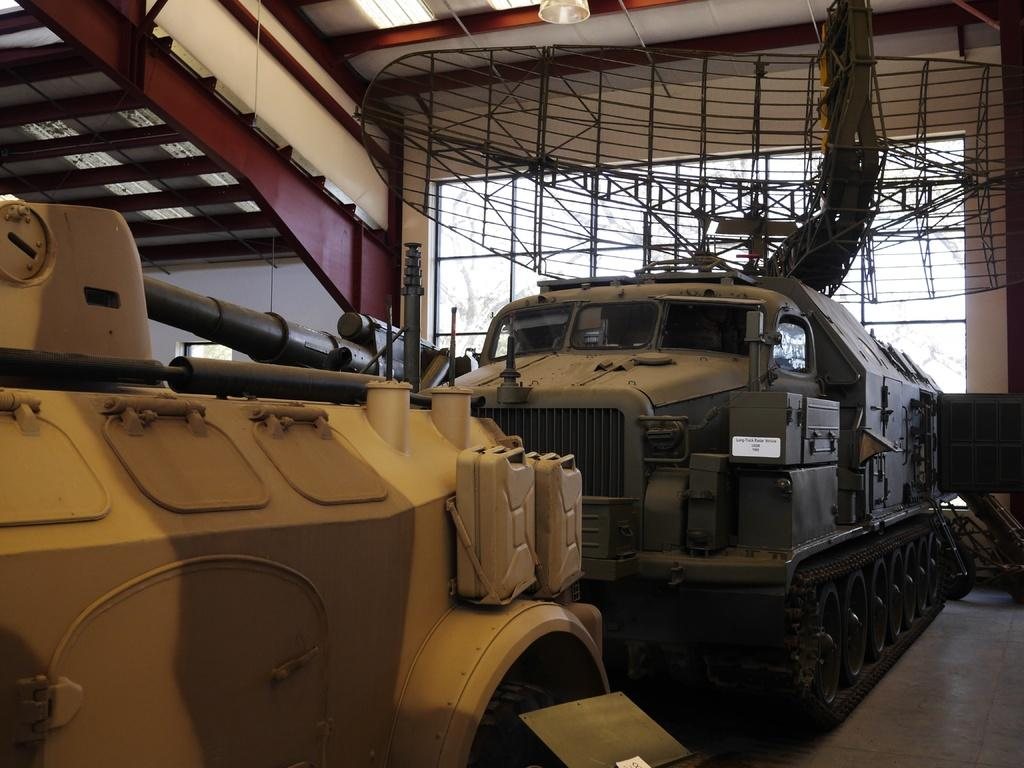What is present in the image? There are vehicles in the image. What colors are the vehicles? The vehicles are in grey and yellow colors. Where are the vehicles located? The vehicles are in a shed. What can be seen on the roof in the image? There is a red and white color roof in the image. What type of guitar is being played at the event in the image? There is no guitar or event present in the image; it features vehicles in a shed. How many cards are visible on the table in the image? There are no cards or table present in the image; it features vehicles in a shed with a red and white color roof. 